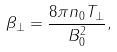<formula> <loc_0><loc_0><loc_500><loc_500>\beta _ { \perp } = \frac { 8 \pi n _ { 0 } T _ { \perp } } { B _ { 0 } ^ { 2 } } ,</formula> 